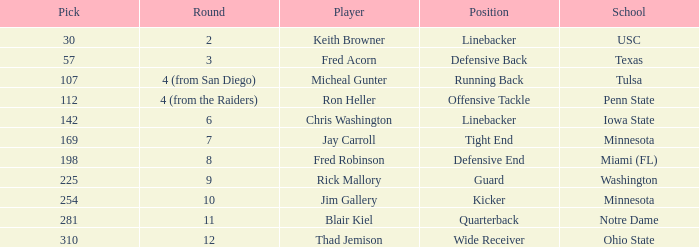Which Round is pick 112 in? 4 (from the Raiders). 